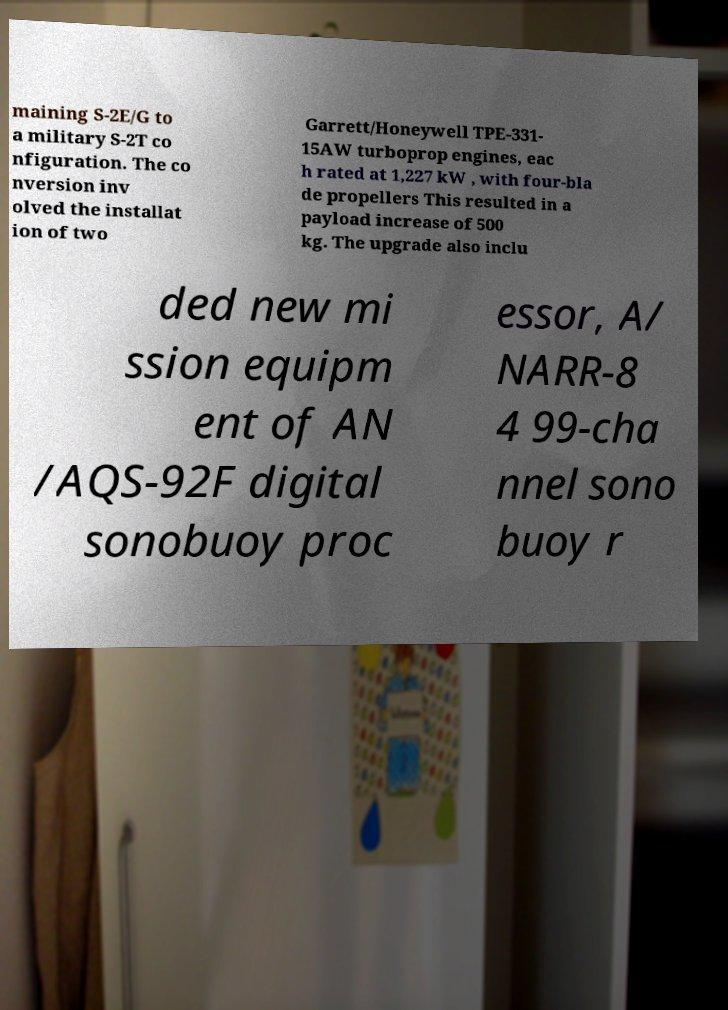Please read and relay the text visible in this image. What does it say? maining S-2E/G to a military S-2T co nfiguration. The co nversion inv olved the installat ion of two Garrett/Honeywell TPE-331- 15AW turboprop engines, eac h rated at 1,227 kW , with four-bla de propellers This resulted in a payload increase of 500 kg. The upgrade also inclu ded new mi ssion equipm ent of AN /AQS-92F digital sonobuoy proc essor, A/ NARR-8 4 99-cha nnel sono buoy r 